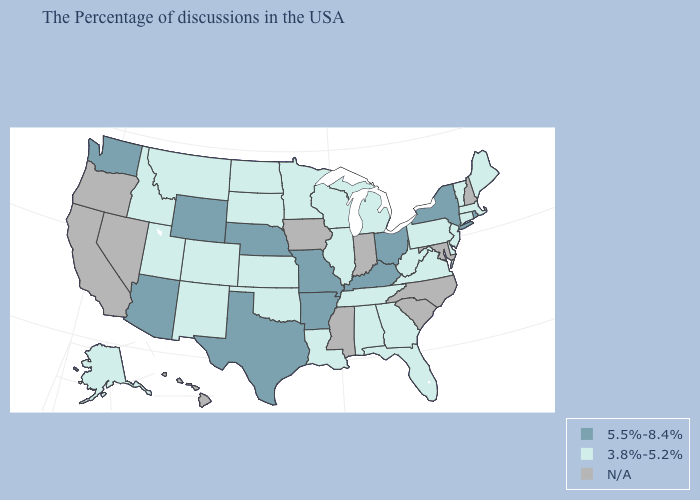Which states have the lowest value in the USA?
Be succinct. Maine, Massachusetts, Vermont, Connecticut, New Jersey, Delaware, Pennsylvania, Virginia, West Virginia, Florida, Georgia, Michigan, Alabama, Tennessee, Wisconsin, Illinois, Louisiana, Minnesota, Kansas, Oklahoma, South Dakota, North Dakota, Colorado, New Mexico, Utah, Montana, Idaho, Alaska. Which states hav the highest value in the West?
Be succinct. Wyoming, Arizona, Washington. Does the map have missing data?
Concise answer only. Yes. Does the first symbol in the legend represent the smallest category?
Give a very brief answer. No. Which states have the lowest value in the Northeast?
Quick response, please. Maine, Massachusetts, Vermont, Connecticut, New Jersey, Pennsylvania. What is the value of Wyoming?
Concise answer only. 5.5%-8.4%. Among the states that border Tennessee , which have the highest value?
Give a very brief answer. Kentucky, Missouri, Arkansas. Name the states that have a value in the range 5.5%-8.4%?
Concise answer only. Rhode Island, New York, Ohio, Kentucky, Missouri, Arkansas, Nebraska, Texas, Wyoming, Arizona, Washington. What is the value of Idaho?
Concise answer only. 3.8%-5.2%. Name the states that have a value in the range 5.5%-8.4%?
Quick response, please. Rhode Island, New York, Ohio, Kentucky, Missouri, Arkansas, Nebraska, Texas, Wyoming, Arizona, Washington. Does Michigan have the highest value in the MidWest?
Quick response, please. No. Name the states that have a value in the range 5.5%-8.4%?
Concise answer only. Rhode Island, New York, Ohio, Kentucky, Missouri, Arkansas, Nebraska, Texas, Wyoming, Arizona, Washington. What is the highest value in states that border Mississippi?
Keep it brief. 5.5%-8.4%. Name the states that have a value in the range N/A?
Quick response, please. New Hampshire, Maryland, North Carolina, South Carolina, Indiana, Mississippi, Iowa, Nevada, California, Oregon, Hawaii. 